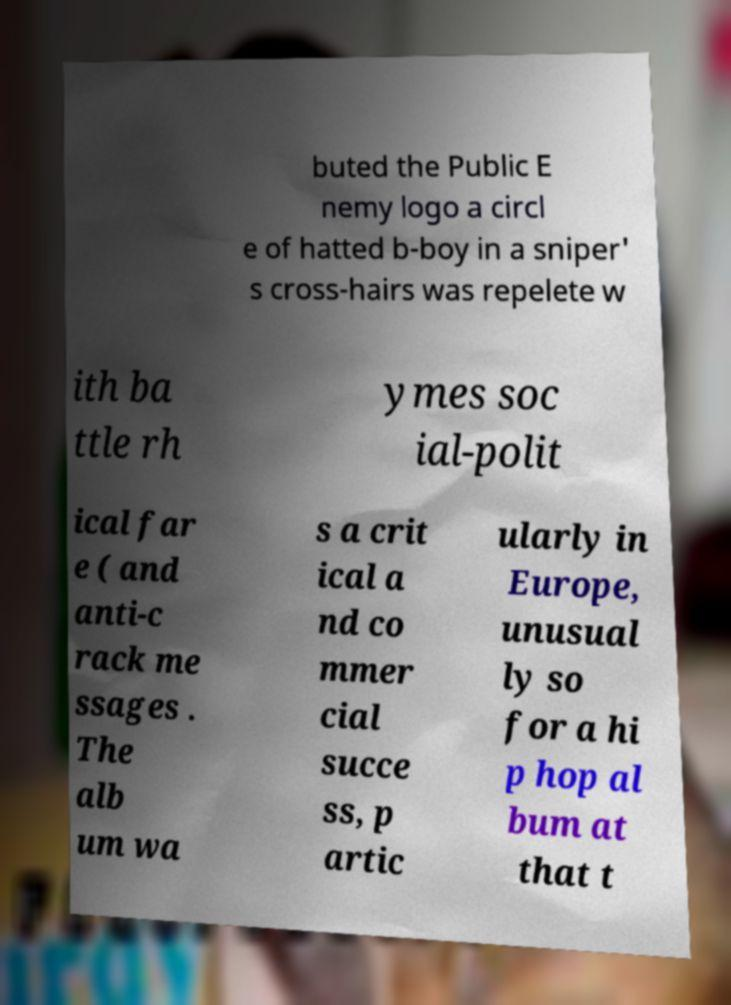Could you assist in decoding the text presented in this image and type it out clearly? buted the Public E nemy logo a circl e of hatted b-boy in a sniper' s cross-hairs was repelete w ith ba ttle rh ymes soc ial-polit ical far e ( and anti-c rack me ssages . The alb um wa s a crit ical a nd co mmer cial succe ss, p artic ularly in Europe, unusual ly so for a hi p hop al bum at that t 